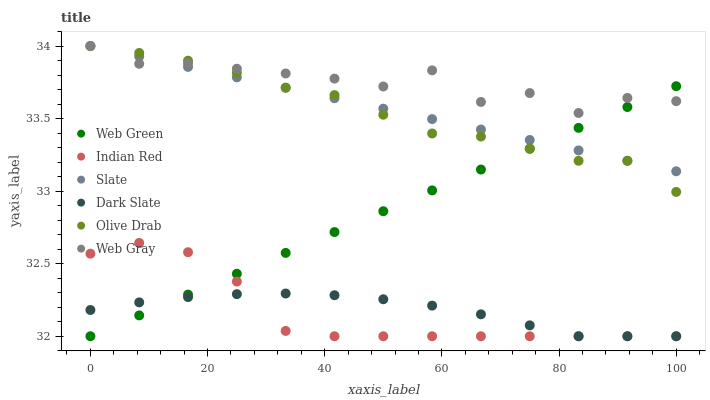Does Indian Red have the minimum area under the curve?
Answer yes or no. Yes. Does Web Gray have the maximum area under the curve?
Answer yes or no. Yes. Does Slate have the minimum area under the curve?
Answer yes or no. No. Does Slate have the maximum area under the curve?
Answer yes or no. No. Is Web Green the smoothest?
Answer yes or no. Yes. Is Web Gray the roughest?
Answer yes or no. Yes. Is Slate the smoothest?
Answer yes or no. No. Is Slate the roughest?
Answer yes or no. No. Does Web Green have the lowest value?
Answer yes or no. Yes. Does Slate have the lowest value?
Answer yes or no. No. Does Olive Drab have the highest value?
Answer yes or no. Yes. Does Web Green have the highest value?
Answer yes or no. No. Is Indian Red less than Slate?
Answer yes or no. Yes. Is Slate greater than Indian Red?
Answer yes or no. Yes. Does Web Green intersect Dark Slate?
Answer yes or no. Yes. Is Web Green less than Dark Slate?
Answer yes or no. No. Is Web Green greater than Dark Slate?
Answer yes or no. No. Does Indian Red intersect Slate?
Answer yes or no. No. 